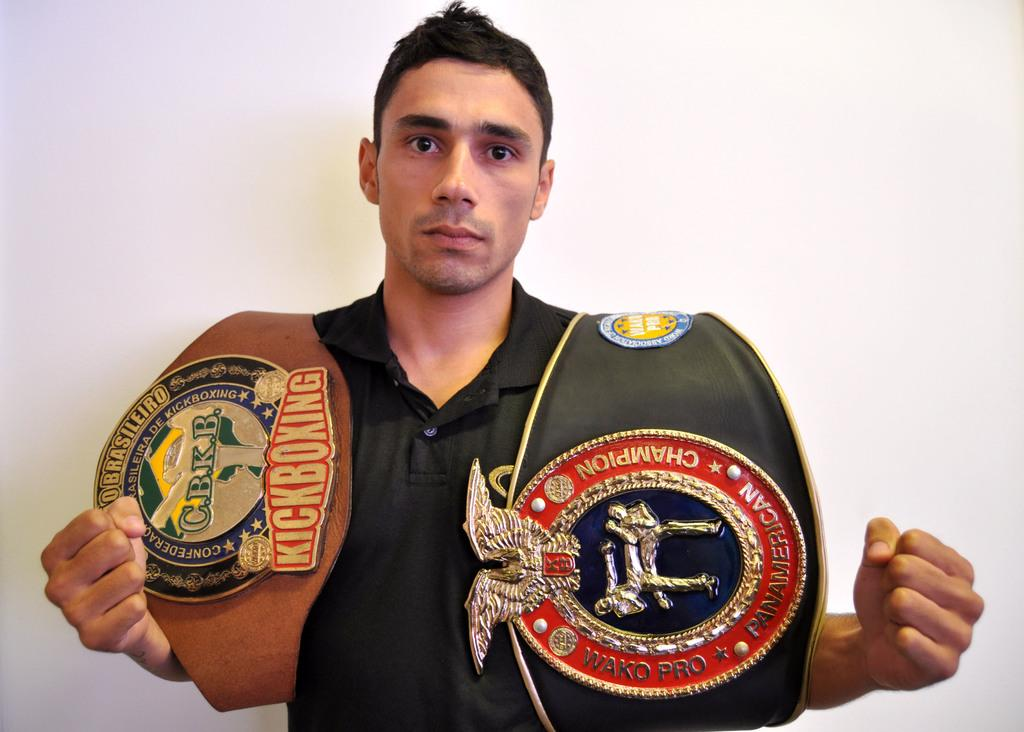What is the main subject of the image? The main subject of the image is a man standing. What is the man holding in his hands? The man is holding armors in his hands. What type of insect can be seen flying around the man in the image? There is no insect present in the image. Is the man in the image engaged in a fight or flight? The image does not depict the man in a fight or flight situation. 